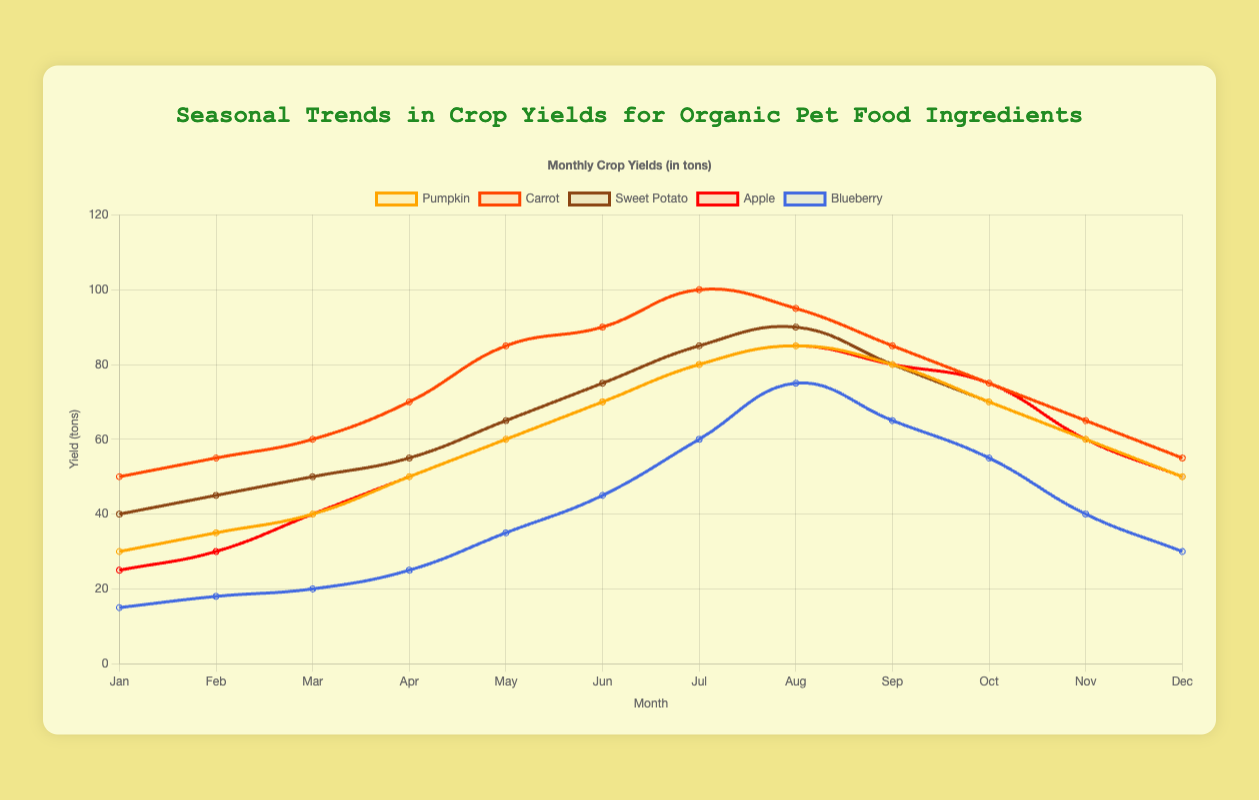What is the month with the highest blueberry yield? To find the month with the highest blueberry yield, we look at the Blueberry trend line and identify the peak value. The highest yield for Blueberries is 75 tons, which occurs in August.
Answer: August In which month do pumpkin yields reach their maximum? We observe the orange line representing the Pumpkin yields and determine the month with the highest peak. This peak is at 85 tons in August.
Answer: August How much higher is the carrot yield in July compared to January? First, find the carrot yield in January (50 tons) and in July (100 tons). Subtract the January yield from the July yield: 100 - 50.
Answer: 50 tons Which crop has the steepest increase in yields from January to July? By examining the slopes of the lines from January to July, we look for the steepest upward trend. The carrot yield increases from 50 to 100, which is a significant change of 50 tons and the steepest among others.
Answer: Carrot What is the total yield of sweet potatoes from January to December? Add all the values of Sweet Potato yields for each month: 40 + 45 + 50 + 55 + 65 + 75 + 85 + 90 + 80 + 70 + 60 + 50 = 765.
Answer: 765 tons Which month has the lowest apple yield, and what is the yield? The lowest value on the red line representing apples can be found. The minimum value is 25 tons in January.
Answer: January, 25 tons How do the apple yields in June compare to those in December? Look at the Apple yield in June (70 tons) and December (50 tons). Compare them to see that the June yield is higher.
Answer: June has higher yields What is the median value of the monthly blueberry yields? List the monthly blueberry yields in ascending order: 15, 18, 20, 25, 30, 35, 40, 45, 55, 60, 65, 75. The median is calculated as the average of the 6th and 7th values: (35 + 40) / 2 = 37.5.
Answer: 37.5 tons Which crop experiences the smallest fluctuation in yield throughout the year? Observe the range (highest to lowest values) for each crop. Pumpkins vary from 30 to 85 (55 tons), Carrots vary from 50 to 100 (50 tons), Sweet Potatoes vary from 40 to 90 (50 tons), Apples vary from 25 to 85 (60 tons), and Blueberries vary from 15 to 75 (60 tons). Carrots and Sweet Potatoes have the smallest fluctuation at 50 tons.
Answer: Carrot and Sweet Potato 